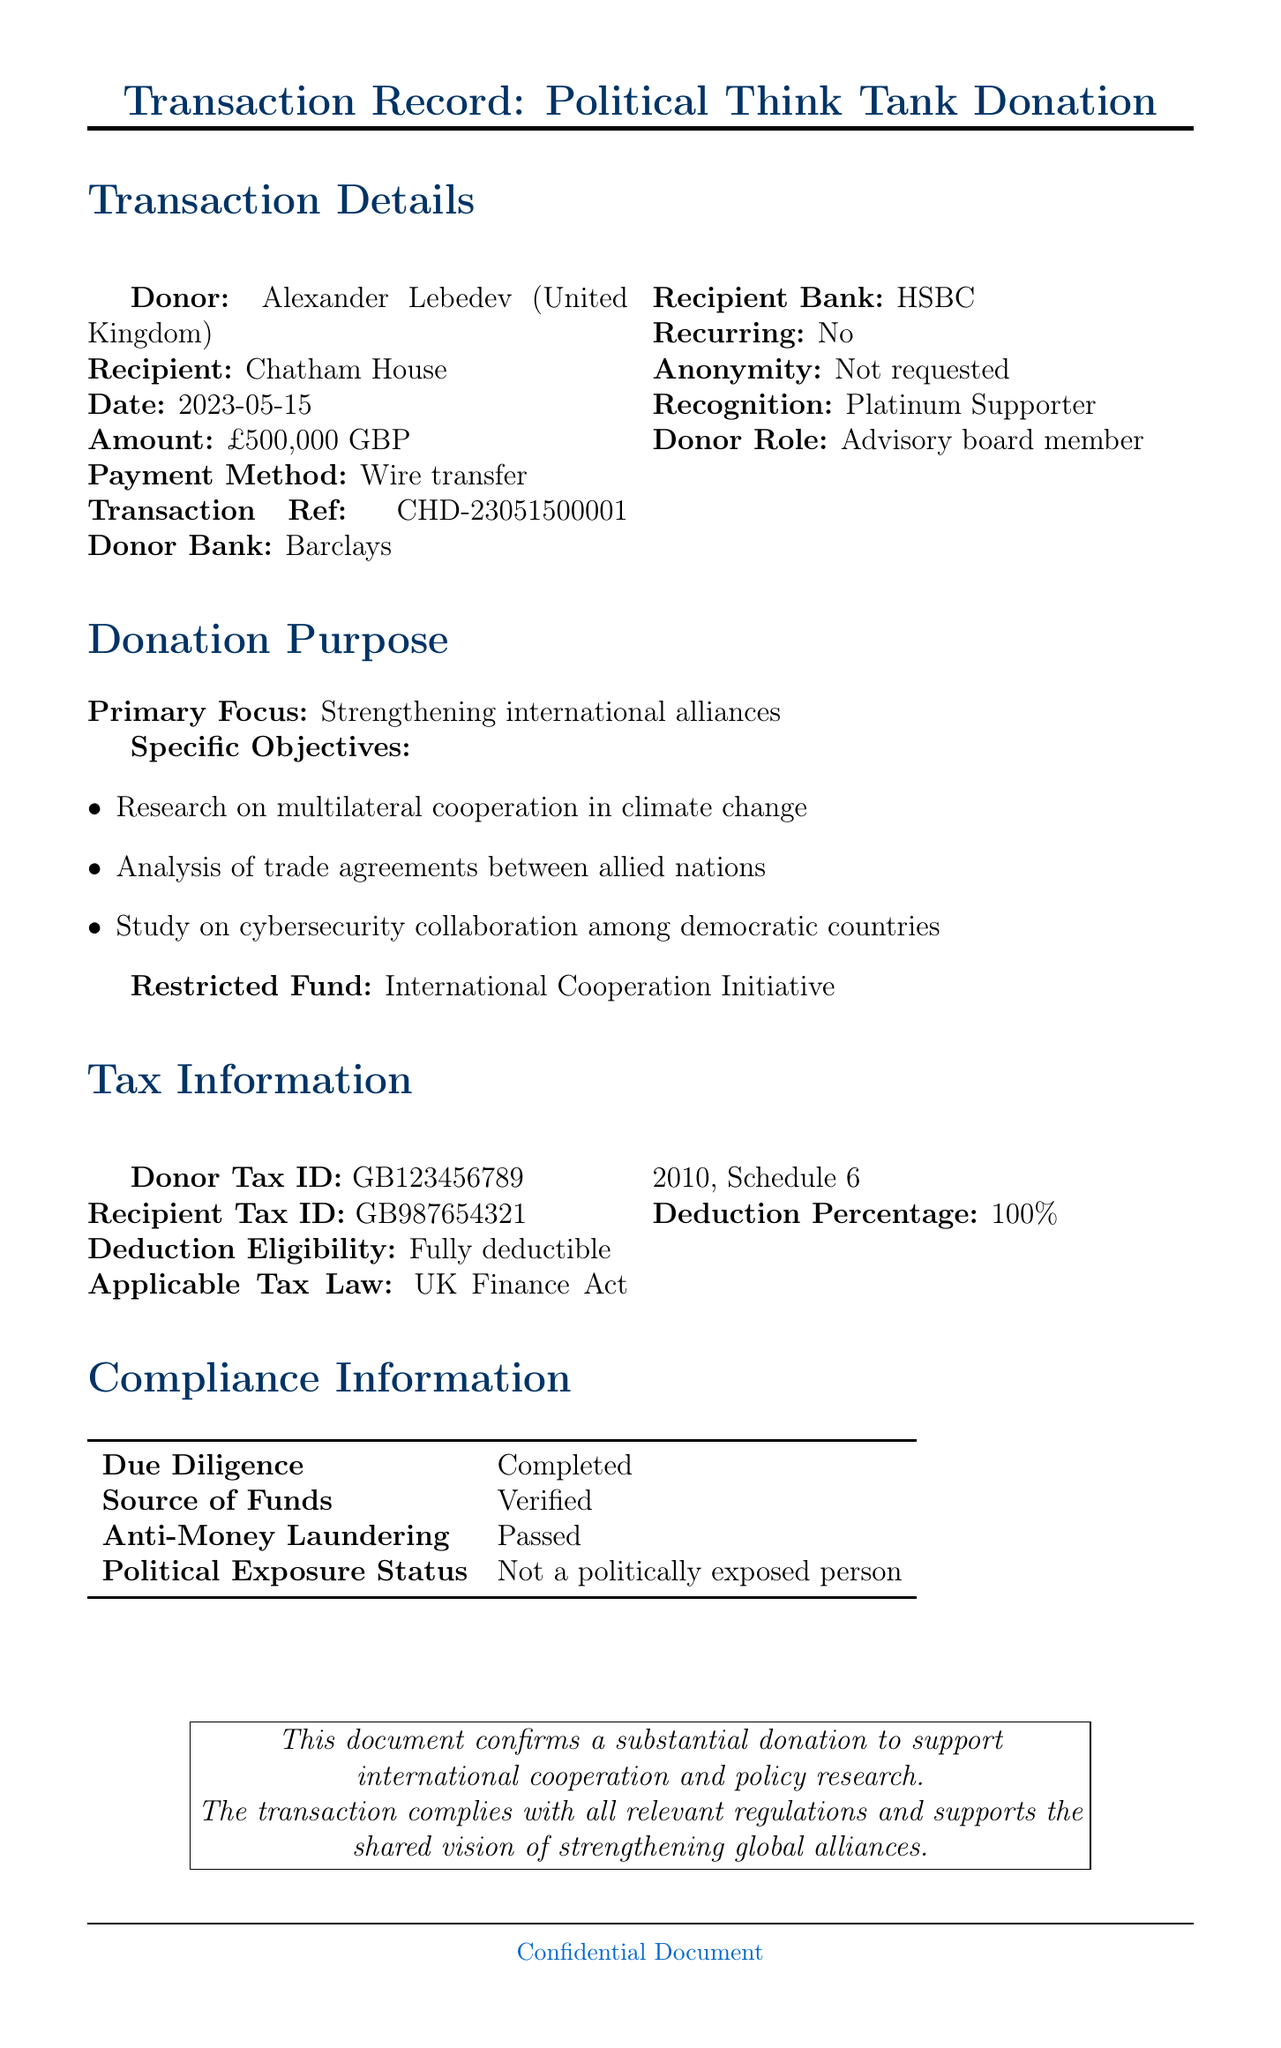What is the name of the donor? The donor's name is stated in the transaction details section of the document.
Answer: Alexander Lebedev What is the recipient organization? The document specifies the organization that received the donation.
Answer: Chatham House What is the donation amount? The document clearly mentions the total amount of the donation made.
Answer: £500,000 When was the transaction date? The date of the transaction is provided in the transaction details section.
Answer: 2023-05-15 What is the primary focus of the donation? The document outlines the main focus area of the donation explicitly.
Answer: Strengthening international alliances What is the eligibility for tax deduction? The tax information section indicates whether the donation is deductible and to what extent.
Answer: Fully deductible What percentage of the donation is tax-deductible? The document specifies the percentage of the donation eligible for deduction.
Answer: 100% Is the donor a member of an advisory board? The document includes information about the donor's involvement with the recipient organization.
Answer: Yes What is the donor's tax ID? The document lists the tax identification number provided for the donor.
Answer: GB123456789 